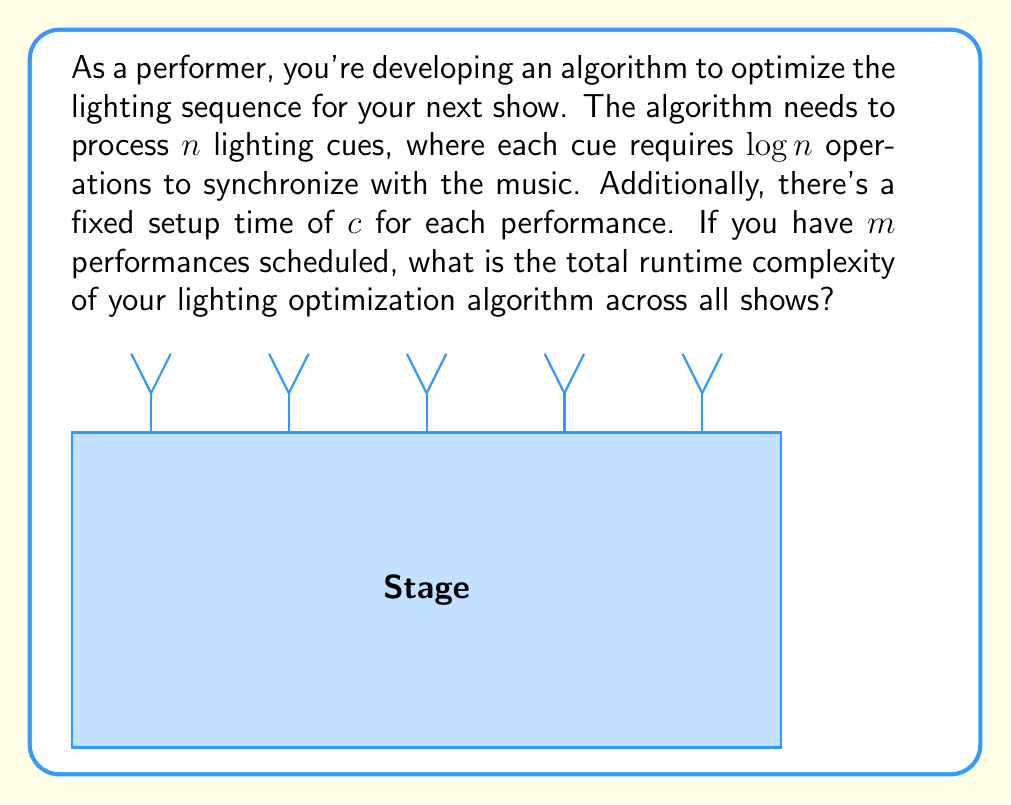Teach me how to tackle this problem. Let's break this down step-by-step:

1) For each performance:
   - We have a fixed setup time of $c$.
   - We need to process $n$ lighting cues.
   - Each cue requires $\log n$ operations.

2) The time complexity for processing all cues in one performance is:
   $$T(n) = n \cdot \log n$$

3) Adding the fixed setup time $c$, the total time for one performance is:
   $$T(n) = n \cdot \log n + c$$

4) We have $m$ performances, so we multiply the above by $m$:
   $$T(n,m) = m \cdot (n \cdot \log n + c)$$

5) Expanding the brackets:
   $$T(n,m) = m \cdot n \cdot \log n + m \cdot c$$

6) In Big O notation, we focus on the dominant term as $n$ and $m$ grow large. The $m \cdot c$ term becomes insignificant compared to $m \cdot n \cdot \log n$.

Therefore, the runtime complexity across all shows is $O(m \cdot n \cdot \log n)$.
Answer: $O(m \cdot n \cdot \log n)$ 